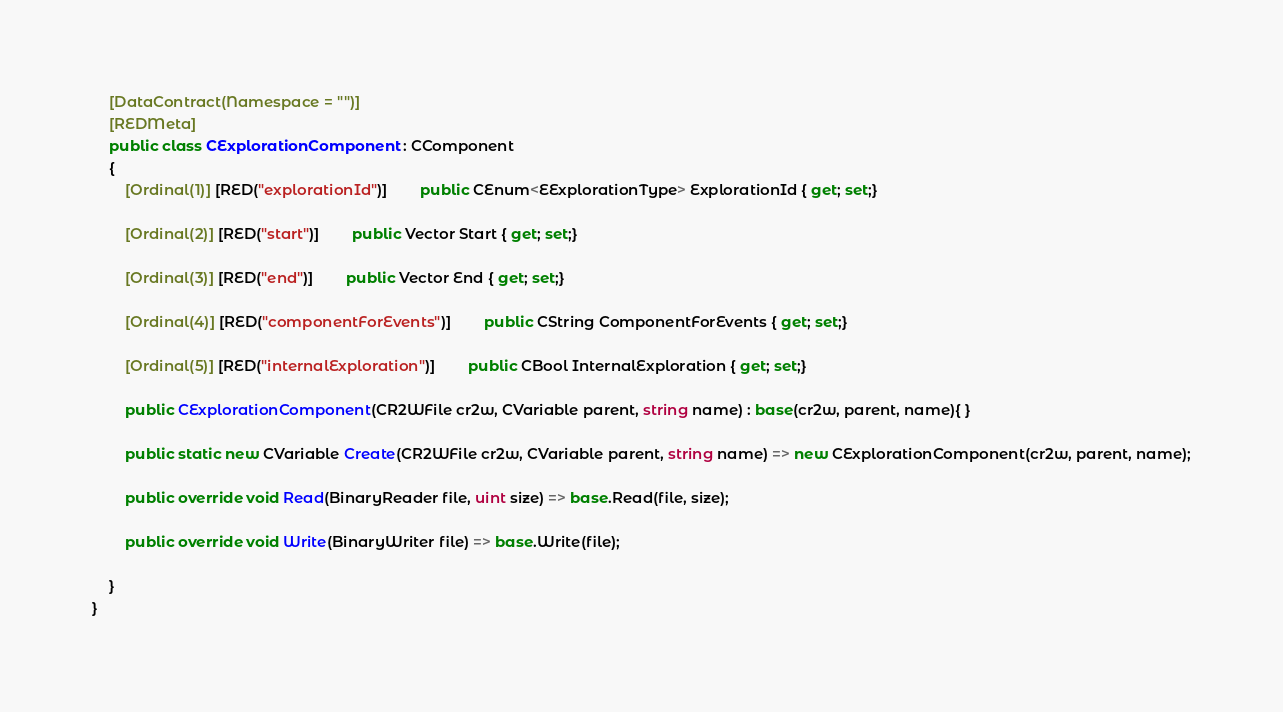<code> <loc_0><loc_0><loc_500><loc_500><_C#_>	[DataContract(Namespace = "")]
	[REDMeta]
	public class CExplorationComponent : CComponent
	{
		[Ordinal(1)] [RED("explorationId")] 		public CEnum<EExplorationType> ExplorationId { get; set;}

		[Ordinal(2)] [RED("start")] 		public Vector Start { get; set;}

		[Ordinal(3)] [RED("end")] 		public Vector End { get; set;}

		[Ordinal(4)] [RED("componentForEvents")] 		public CString ComponentForEvents { get; set;}

		[Ordinal(5)] [RED("internalExploration")] 		public CBool InternalExploration { get; set;}

		public CExplorationComponent(CR2WFile cr2w, CVariable parent, string name) : base(cr2w, parent, name){ }

		public static new CVariable Create(CR2WFile cr2w, CVariable parent, string name) => new CExplorationComponent(cr2w, parent, name);

		public override void Read(BinaryReader file, uint size) => base.Read(file, size);

		public override void Write(BinaryWriter file) => base.Write(file);

	}
}</code> 